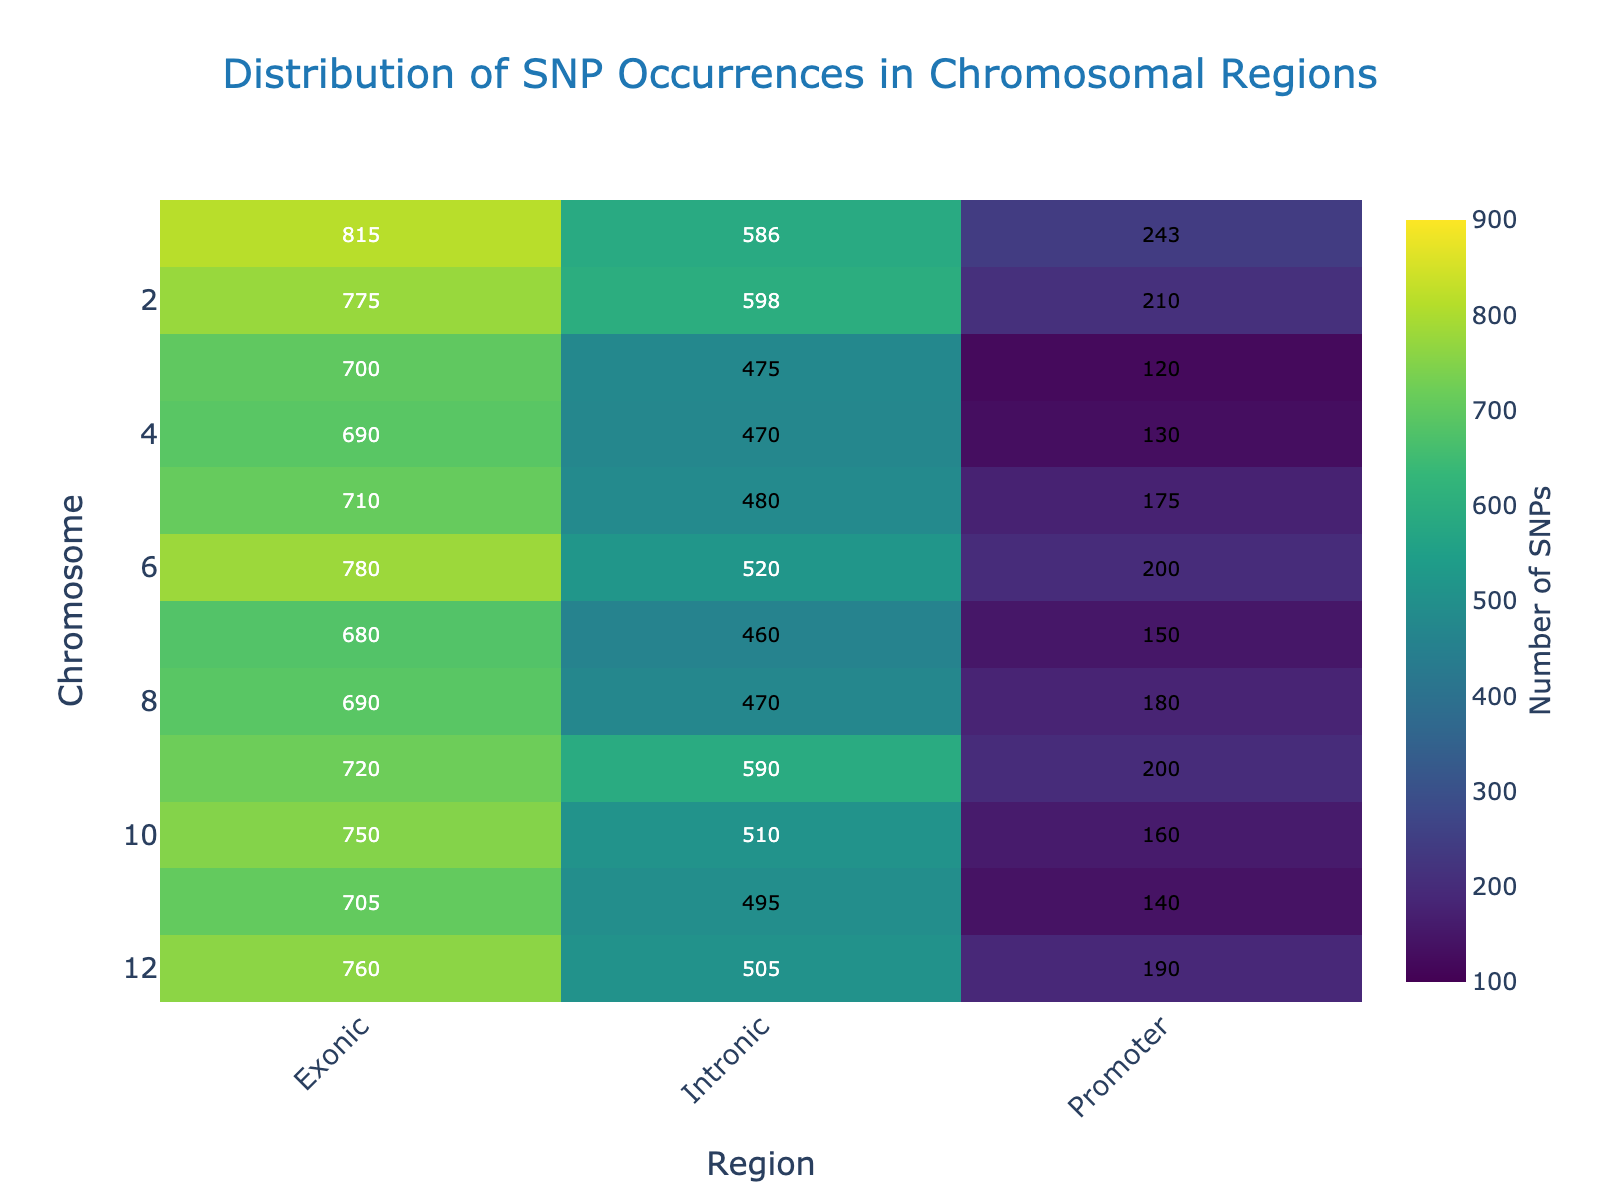What is the title of the heatmap? The title is located at the top of the heatmap. It reads "Distribution of SNP Occurrences in Chromosomal Regions".
Answer: Distribution of SNP Occurrences in Chromosomal Regions Which chromosome has the highest number of SNPs in the exonic region? To find this, look at the "Exonic" column and identify the row with the highest value. The highest number is 815, which corresponds to Chromosome 1.
Answer: Chromosome 1 How many SNPs are there in total across Chromosome 1? Sum the values for Chromosome 1 in all regions (Promoter, Exonic, Intronic). 243 (Promoter) + 815 (Exonic) + 586 (Intronic) = 1644
Answer: 1644 Are there more SNPs in the exonic or intronic region of Chromosome 7? Compare the values in the corresponding row for Chromosome 7. There are 680 SNPs in the exonic region and 460 SNPs in the intronic region, so there are more SNPs in the exonic region.
Answer: Exonic Which chromosomal region has the least number of SNPs? Look for the smallest number in the heatmap. The smallest number is 120, found in the Promoter region of Chromosome 3.
Answer: Promoter region of Chromosome 3 What is the average number of SNPs in the intronic regions across all chromosomes? Add all values in the Intronic column and divide by the number of entries (12 chromosomes). The sum is 6749 and the average is 6749/12 ≈ 562.42.
Answer: 562.42 Which chromosomes have more SNPs in the promoter region than in the intronic region? Compare values for Promoter and Intronic regions for each chromosome. Chromosomes 3, 4, and 7 have more SNPs in the Promoter region than in the Intronic region.
Answer: Chromosomes 3, 4, and 7 What is the total number of SNPs in exonic regions across all chromosomes? Sum the values in the Exonic column. The sum is 10970.
Answer: 10970 Which region of Chromosome 6 has the smallest number of SNPs? Look at the row for Chromosome 6 and identify the smallest number. The smallest value is 200 in the Promoter region.
Answer: Promoter What is the color scale used in the heatmap? The heatmap uses the "Viridis" color scale, which ranges from dark blue (lowest) to yellow (highest).
Answer: Viridis 